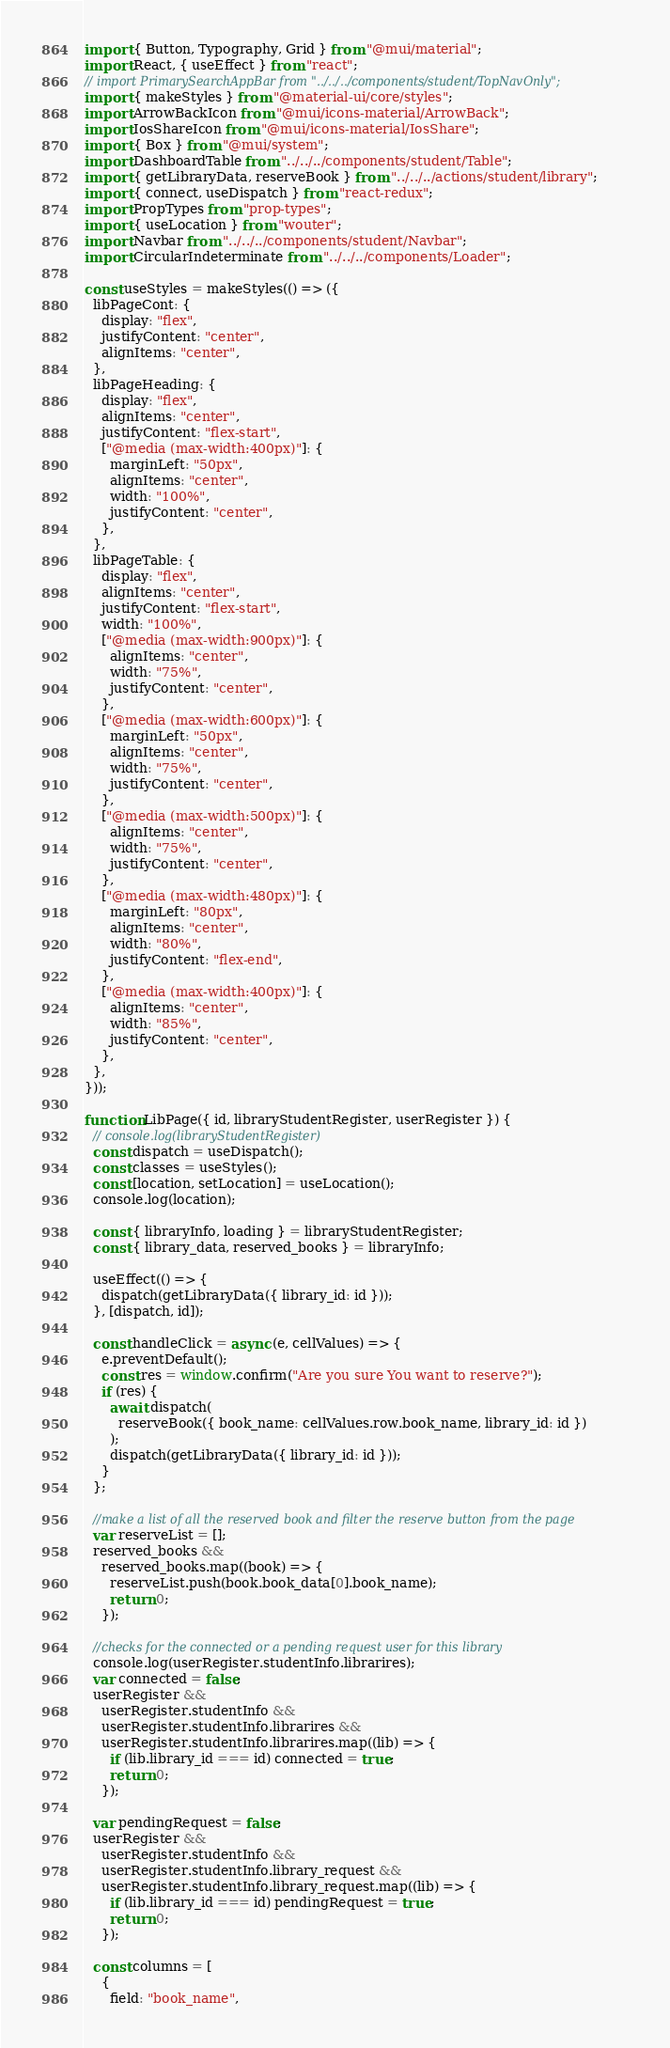<code> <loc_0><loc_0><loc_500><loc_500><_JavaScript_>import { Button, Typography, Grid } from "@mui/material";
import React, { useEffect } from "react";
// import PrimarySearchAppBar from "../../../components/student/TopNavOnly";
import { makeStyles } from "@material-ui/core/styles";
import ArrowBackIcon from "@mui/icons-material/ArrowBack";
import IosShareIcon from "@mui/icons-material/IosShare";
import { Box } from "@mui/system";
import DashboardTable from "../../../components/student/Table";
import { getLibraryData, reserveBook } from "../../../actions/student/library";
import { connect, useDispatch } from "react-redux";
import PropTypes from "prop-types";
import { useLocation } from "wouter";
import Navbar from "../../../components/student/Navbar";
import CircularIndeterminate from "../../../components/Loader";

const useStyles = makeStyles(() => ({
  libPageCont: {
    display: "flex",
    justifyContent: "center",
    alignItems: "center",
  },
  libPageHeading: {
    display: "flex",
    alignItems: "center",
    justifyContent: "flex-start",
    ["@media (max-width:400px)"]: {
      marginLeft: "50px",
      alignItems: "center",
      width: "100%",
      justifyContent: "center",
    },
  },
  libPageTable: {
    display: "flex",
    alignItems: "center",
    justifyContent: "flex-start",
    width: "100%",
    ["@media (max-width:900px)"]: {
      alignItems: "center",
      width: "75%",
      justifyContent: "center",
    },
    ["@media (max-width:600px)"]: {
      marginLeft: "50px",
      alignItems: "center",
      width: "75%",
      justifyContent: "center",
    },
    ["@media (max-width:500px)"]: {
      alignItems: "center",
      width: "75%",
      justifyContent: "center",
    },
    ["@media (max-width:480px)"]: {
      marginLeft: "80px",
      alignItems: "center",
      width: "80%",
      justifyContent: "flex-end",
    },
    ["@media (max-width:400px)"]: {
      alignItems: "center",
      width: "85%",
      justifyContent: "center",
    },
  },
}));

function LibPage({ id, libraryStudentRegister, userRegister }) {
  // console.log(libraryStudentRegister)
  const dispatch = useDispatch();
  const classes = useStyles();
  const [location, setLocation] = useLocation();
  console.log(location);

  const { libraryInfo, loading } = libraryStudentRegister;
  const { library_data, reserved_books } = libraryInfo;

  useEffect(() => {
    dispatch(getLibraryData({ library_id: id }));
  }, [dispatch, id]);

  const handleClick = async (e, cellValues) => {
    e.preventDefault();
    const res = window.confirm("Are you sure You want to reserve?");
    if (res) {
      await dispatch(
        reserveBook({ book_name: cellValues.row.book_name, library_id: id })
      );
      dispatch(getLibraryData({ library_id: id }));
    }
  };

  //make a list of all the reserved book and filter the reserve button from the page
  var reserveList = [];
  reserved_books &&
    reserved_books.map((book) => {
      reserveList.push(book.book_data[0].book_name);
      return 0;
    });

  //checks for the connected or a pending request user for this library
  console.log(userRegister.studentInfo.librarires);
  var connected = false;
  userRegister &&
    userRegister.studentInfo &&
    userRegister.studentInfo.librarires &&
    userRegister.studentInfo.librarires.map((lib) => {
      if (lib.library_id === id) connected = true;
      return 0;
    });

  var pendingRequest = false;
  userRegister &&
    userRegister.studentInfo &&
    userRegister.studentInfo.library_request &&
    userRegister.studentInfo.library_request.map((lib) => {
      if (lib.library_id === id) pendingRequest = true;
      return 0;
    });

  const columns = [
    {
      field: "book_name",</code> 